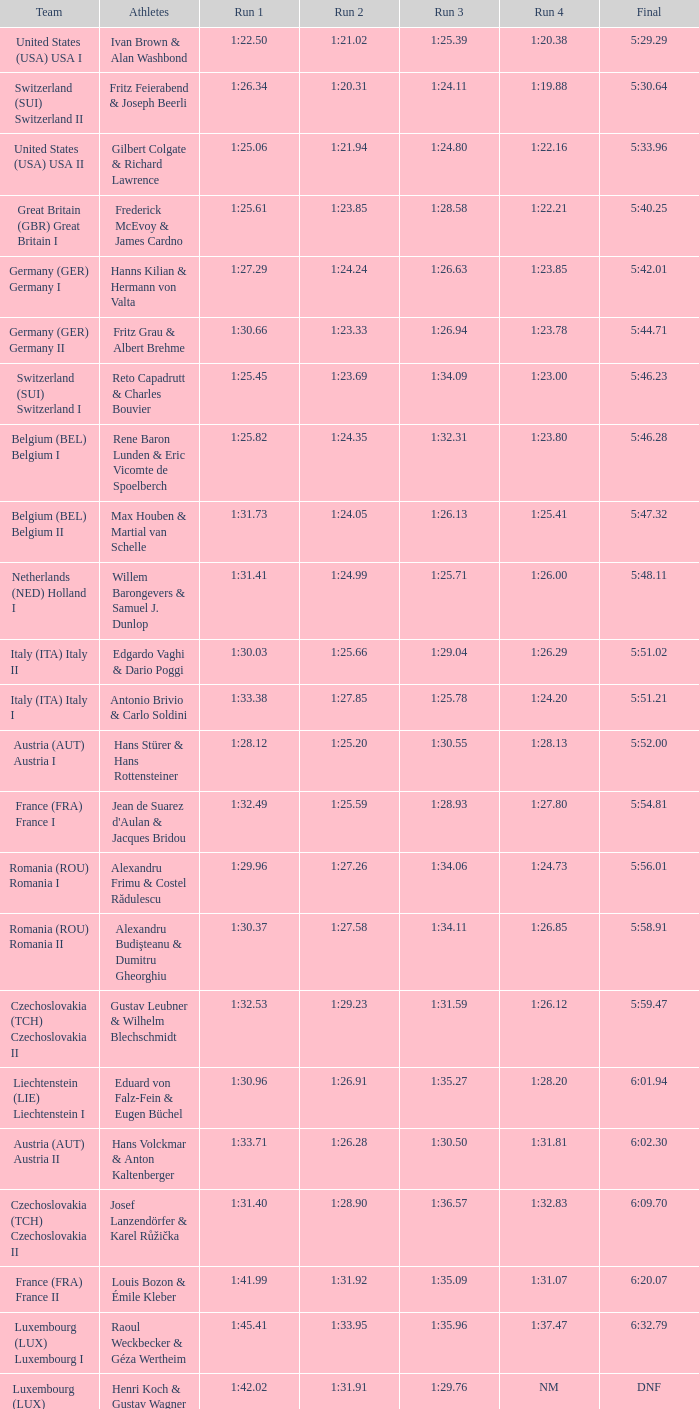63? 1:23.85. 